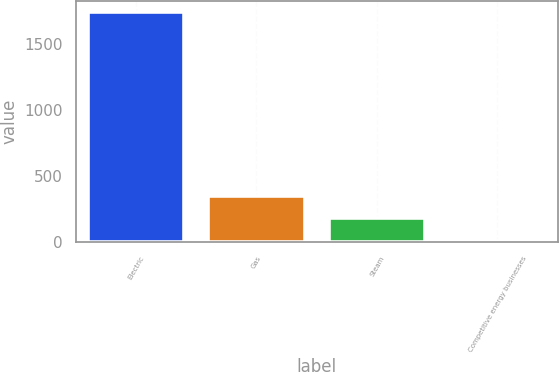Convert chart to OTSL. <chart><loc_0><loc_0><loc_500><loc_500><bar_chart><fcel>Electric<fcel>Gas<fcel>Steam<fcel>Competitive energy businesses<nl><fcel>1743<fcel>351.8<fcel>177.9<fcel>4<nl></chart> 